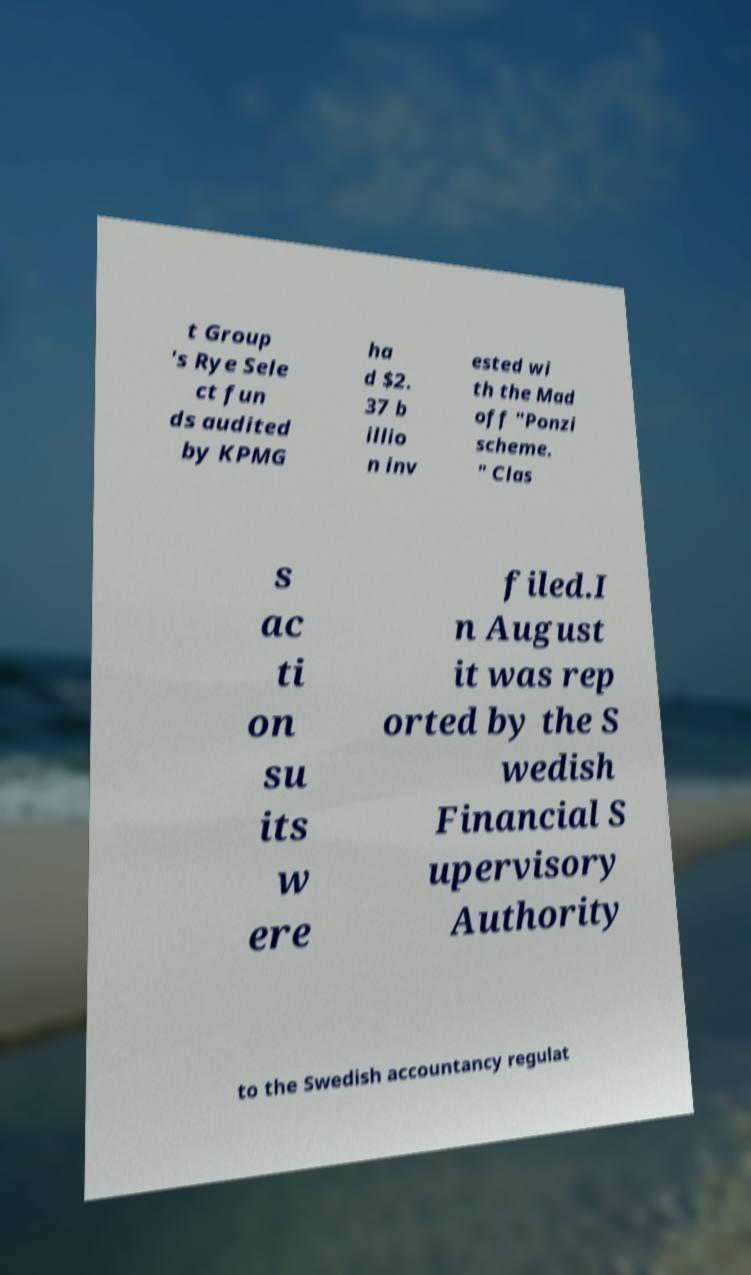Please read and relay the text visible in this image. What does it say? t Group 's Rye Sele ct fun ds audited by KPMG ha d $2. 37 b illio n inv ested wi th the Mad off "Ponzi scheme. " Clas s ac ti on su its w ere filed.I n August it was rep orted by the S wedish Financial S upervisory Authority to the Swedish accountancy regulat 